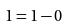<formula> <loc_0><loc_0><loc_500><loc_500>1 = 1 - 0</formula> 